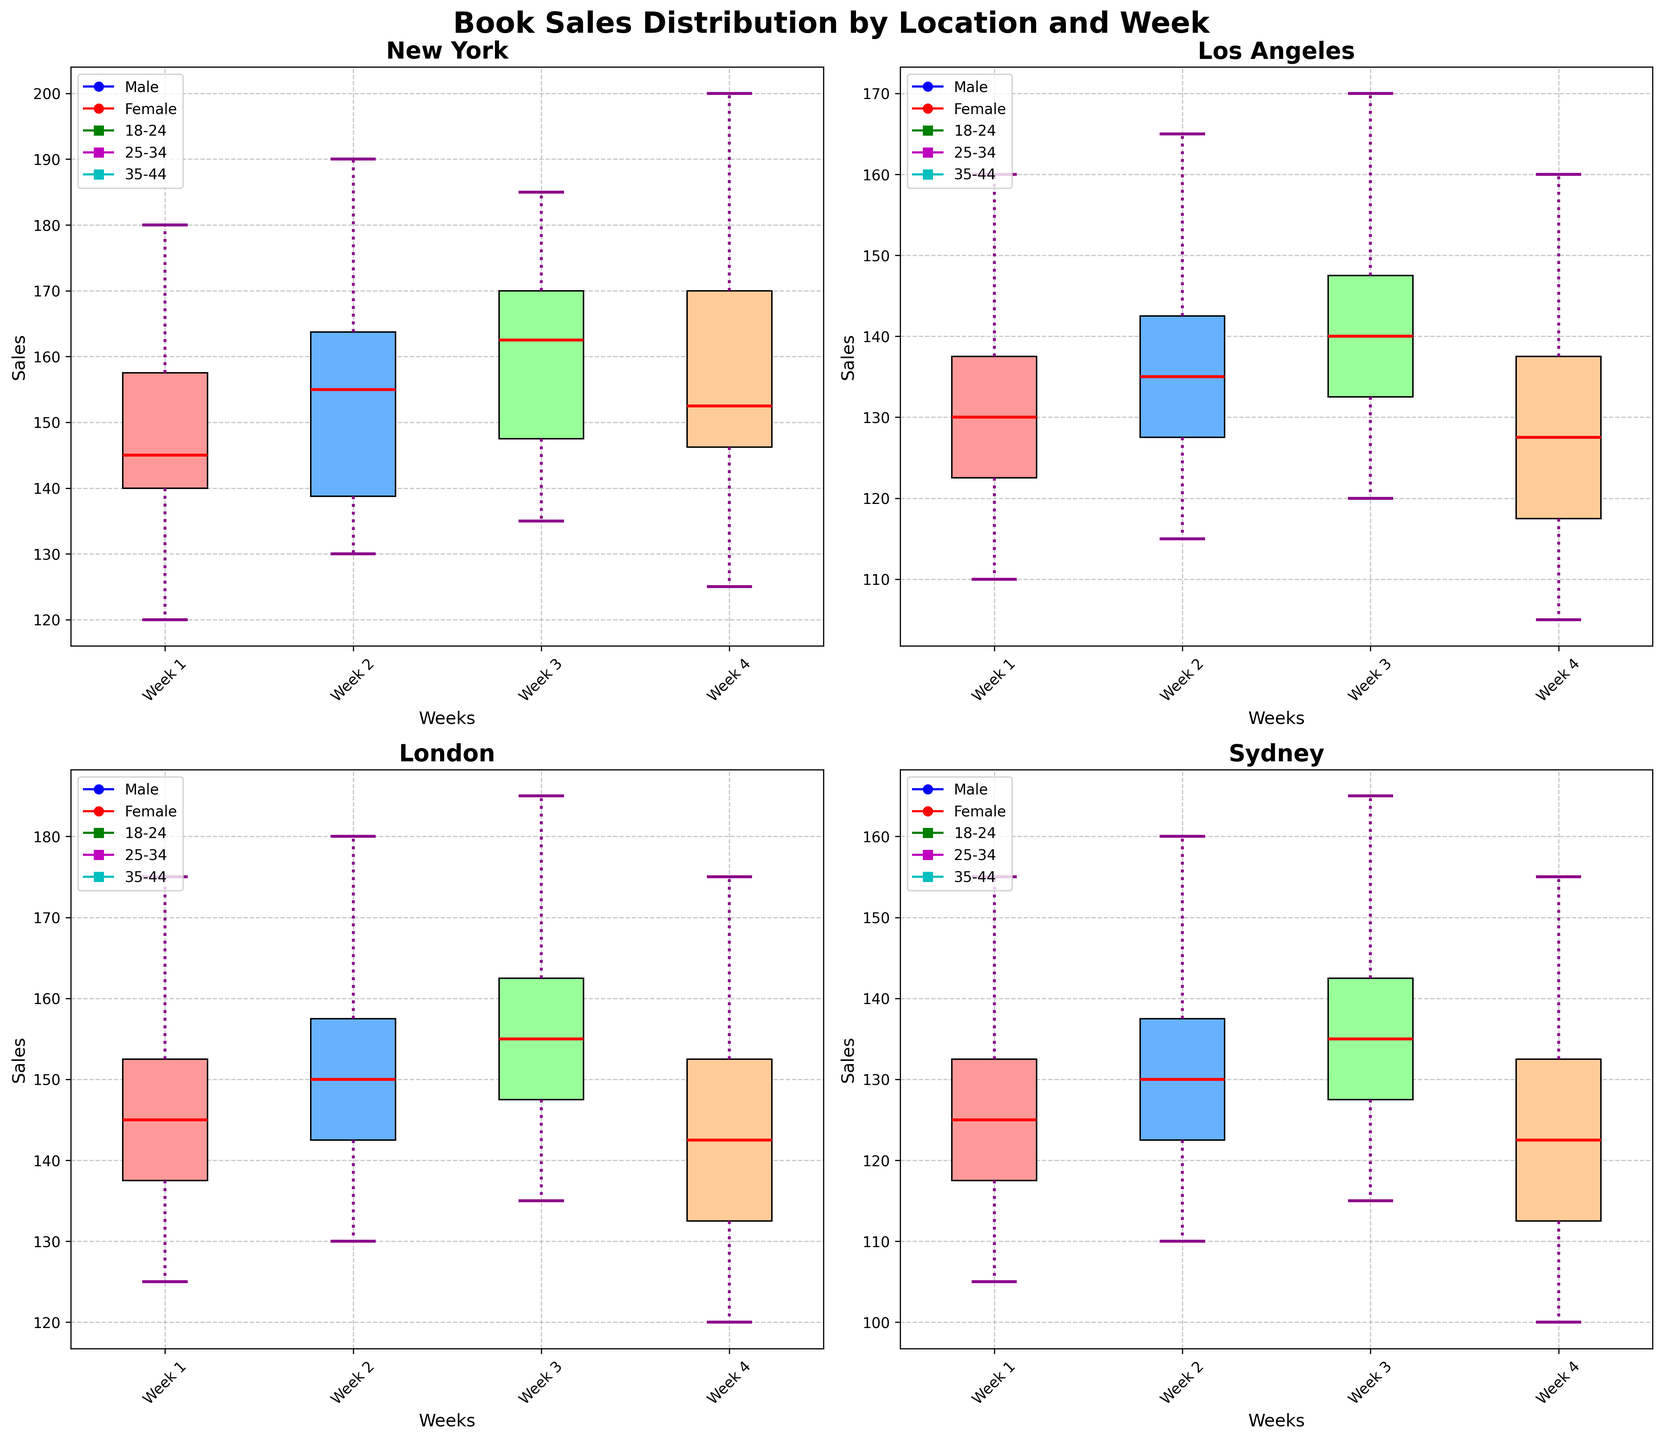Which location has the highest median sales in Week 1? To find the highest median sales in Week 1, look at the central line inside the box of each Week 1 subplot for all locations. Compare the heights of these medians.
Answer: New York What is the range of sales in Week 2 in Los Angeles? The range is calculated as the difference between the highest and lowest points (whiskers) in Week 2's box plot for Los Angeles. Identify the highest and lowest whisker points in the subplot for Los Angeles in Week 2.
Answer: 65 Which weeks in Sydney have the smallest interquartile range (IQR)? To determine the week with the smallest IQR, look at the width of the boxes in each subplot for Sydney. The IQR is the distance between the lower quartile (bottom of the box) and the upper quartile (top of the box).
Answer: Week 2 How does the median sales in Week 4 in London for males compare to females? To compare the medians, examine the central lines inside the boxes in the Week 4 subplot for London. Identify the median for males and females and compare their heights.
Answer: Females have higher median sales What is the difference between the maximum sales in Week 3 and the minimum sales in Week 1 in New York? To find the difference, identify the maximum whisker point in Week 3's box plot and the minimum whisker point in Week 1's box plot for New York. Calculate the difference between these two points.
Answer: 170-120 = 50 Considering the entire plot, which gender generally shows higher variability in sales? To determine this, observe the range and spread of the sales data in each box for both genders across different subplots. The boxes with larger spread (whisker length) indicate higher variability.
Answer: Female Which location shows the most consistent sales across all weeks? Consistency in sales can be identified by observing the overlap of medians and the narrowness of boxes across all weeks for each location. The location with the closest medians and smallest IQRs is the most consistent.
Answer: Sydney Is the sales data from London more variable in Week 1 or Week 3? Variability can be judged by the length of the whiskers and the spread of the boxes in Week 1 and Week 3 for London. Longer whiskers and wider boxes indicate greater variability. Compare these features in Week 1 and Week 3 subplots for London.
Answer: Week 1 What is the median sales value across all locations in Week 2? Identify the median line in the box plot for Week 2 in each subplot and calculate the median of these values across all locations.
Answer: Median values are close to 140-150 